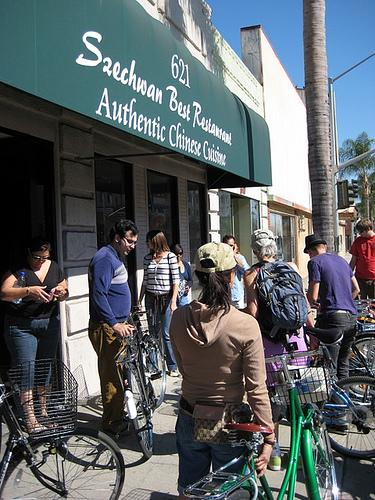What kind of food is most common in this restaurant? Please explain your reasoning. spicy. Szechwan is known for being hot and spicy. 